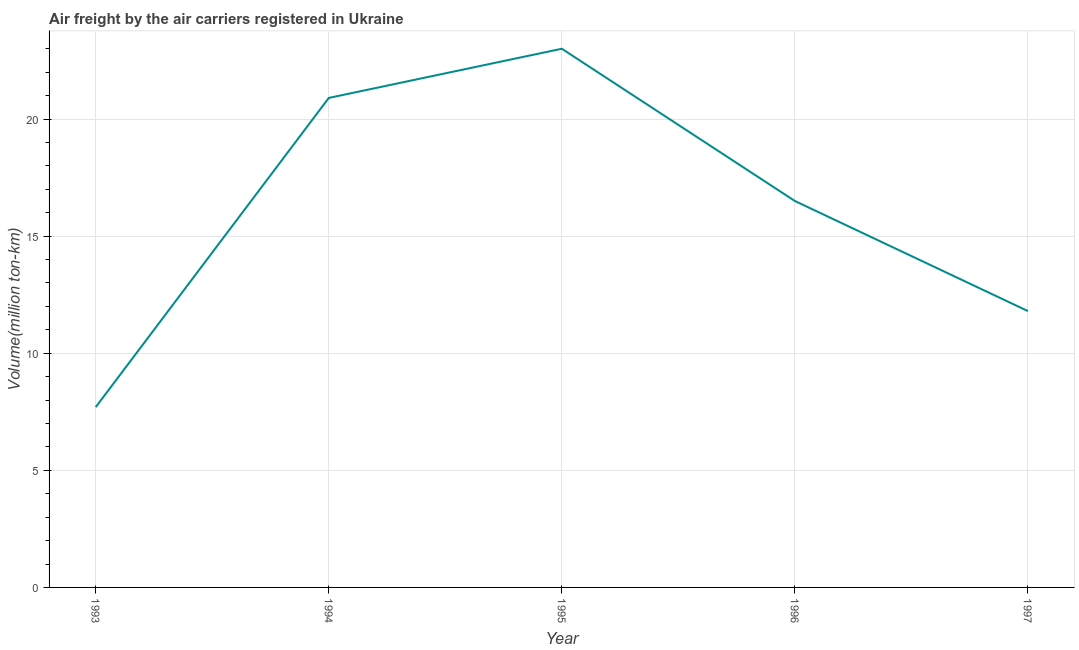What is the air freight in 1997?
Offer a terse response. 11.8. Across all years, what is the minimum air freight?
Your answer should be very brief. 7.7. In which year was the air freight minimum?
Offer a terse response. 1993. What is the sum of the air freight?
Provide a short and direct response. 79.9. What is the difference between the air freight in 1996 and 1997?
Your response must be concise. 4.7. What is the average air freight per year?
Provide a short and direct response. 15.98. What is the ratio of the air freight in 1994 to that in 1995?
Your response must be concise. 0.91. Is the difference between the air freight in 1993 and 1995 greater than the difference between any two years?
Ensure brevity in your answer.  Yes. What is the difference between the highest and the second highest air freight?
Your answer should be very brief. 2.1. What is the difference between the highest and the lowest air freight?
Your answer should be compact. 15.3. In how many years, is the air freight greater than the average air freight taken over all years?
Keep it short and to the point. 3. Does the air freight monotonically increase over the years?
Your answer should be very brief. No. How many years are there in the graph?
Ensure brevity in your answer.  5. What is the difference between two consecutive major ticks on the Y-axis?
Your answer should be very brief. 5. What is the title of the graph?
Ensure brevity in your answer.  Air freight by the air carriers registered in Ukraine. What is the label or title of the Y-axis?
Offer a very short reply. Volume(million ton-km). What is the Volume(million ton-km) in 1993?
Your answer should be compact. 7.7. What is the Volume(million ton-km) of 1994?
Make the answer very short. 20.9. What is the Volume(million ton-km) of 1995?
Your answer should be compact. 23. What is the Volume(million ton-km) in 1996?
Offer a terse response. 16.5. What is the Volume(million ton-km) in 1997?
Provide a short and direct response. 11.8. What is the difference between the Volume(million ton-km) in 1993 and 1994?
Your answer should be compact. -13.2. What is the difference between the Volume(million ton-km) in 1993 and 1995?
Your answer should be very brief. -15.3. What is the difference between the Volume(million ton-km) in 1993 and 1997?
Provide a short and direct response. -4.1. What is the difference between the Volume(million ton-km) in 1994 and 1995?
Give a very brief answer. -2.1. What is the ratio of the Volume(million ton-km) in 1993 to that in 1994?
Your answer should be compact. 0.37. What is the ratio of the Volume(million ton-km) in 1993 to that in 1995?
Keep it short and to the point. 0.34. What is the ratio of the Volume(million ton-km) in 1993 to that in 1996?
Your answer should be compact. 0.47. What is the ratio of the Volume(million ton-km) in 1993 to that in 1997?
Provide a short and direct response. 0.65. What is the ratio of the Volume(million ton-km) in 1994 to that in 1995?
Make the answer very short. 0.91. What is the ratio of the Volume(million ton-km) in 1994 to that in 1996?
Give a very brief answer. 1.27. What is the ratio of the Volume(million ton-km) in 1994 to that in 1997?
Your response must be concise. 1.77. What is the ratio of the Volume(million ton-km) in 1995 to that in 1996?
Your answer should be compact. 1.39. What is the ratio of the Volume(million ton-km) in 1995 to that in 1997?
Offer a very short reply. 1.95. What is the ratio of the Volume(million ton-km) in 1996 to that in 1997?
Provide a short and direct response. 1.4. 